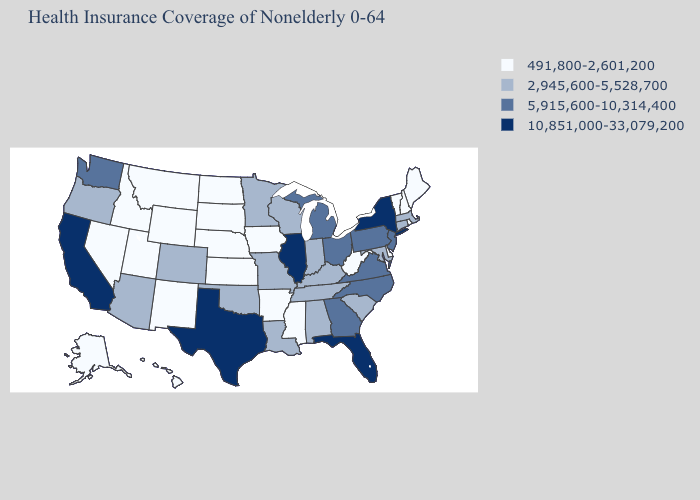Which states hav the highest value in the South?
Write a very short answer. Florida, Texas. Does Pennsylvania have the lowest value in the USA?
Keep it brief. No. Which states have the lowest value in the West?
Keep it brief. Alaska, Hawaii, Idaho, Montana, Nevada, New Mexico, Utah, Wyoming. Among the states that border Pennsylvania , does Delaware have the lowest value?
Keep it brief. Yes. What is the value of New Mexico?
Concise answer only. 491,800-2,601,200. Does New Mexico have the lowest value in the West?
Keep it brief. Yes. Does Colorado have a lower value than New York?
Quick response, please. Yes. Name the states that have a value in the range 2,945,600-5,528,700?
Be succinct. Alabama, Arizona, Colorado, Connecticut, Indiana, Kentucky, Louisiana, Maryland, Massachusetts, Minnesota, Missouri, Oklahoma, Oregon, South Carolina, Tennessee, Wisconsin. Name the states that have a value in the range 5,915,600-10,314,400?
Answer briefly. Georgia, Michigan, New Jersey, North Carolina, Ohio, Pennsylvania, Virginia, Washington. What is the lowest value in states that border Georgia?
Keep it brief. 2,945,600-5,528,700. What is the lowest value in states that border Wyoming?
Be succinct. 491,800-2,601,200. Is the legend a continuous bar?
Keep it brief. No. What is the value of Alaska?
Keep it brief. 491,800-2,601,200. Name the states that have a value in the range 2,945,600-5,528,700?
Be succinct. Alabama, Arizona, Colorado, Connecticut, Indiana, Kentucky, Louisiana, Maryland, Massachusetts, Minnesota, Missouri, Oklahoma, Oregon, South Carolina, Tennessee, Wisconsin. Does Illinois have the highest value in the USA?
Short answer required. Yes. 